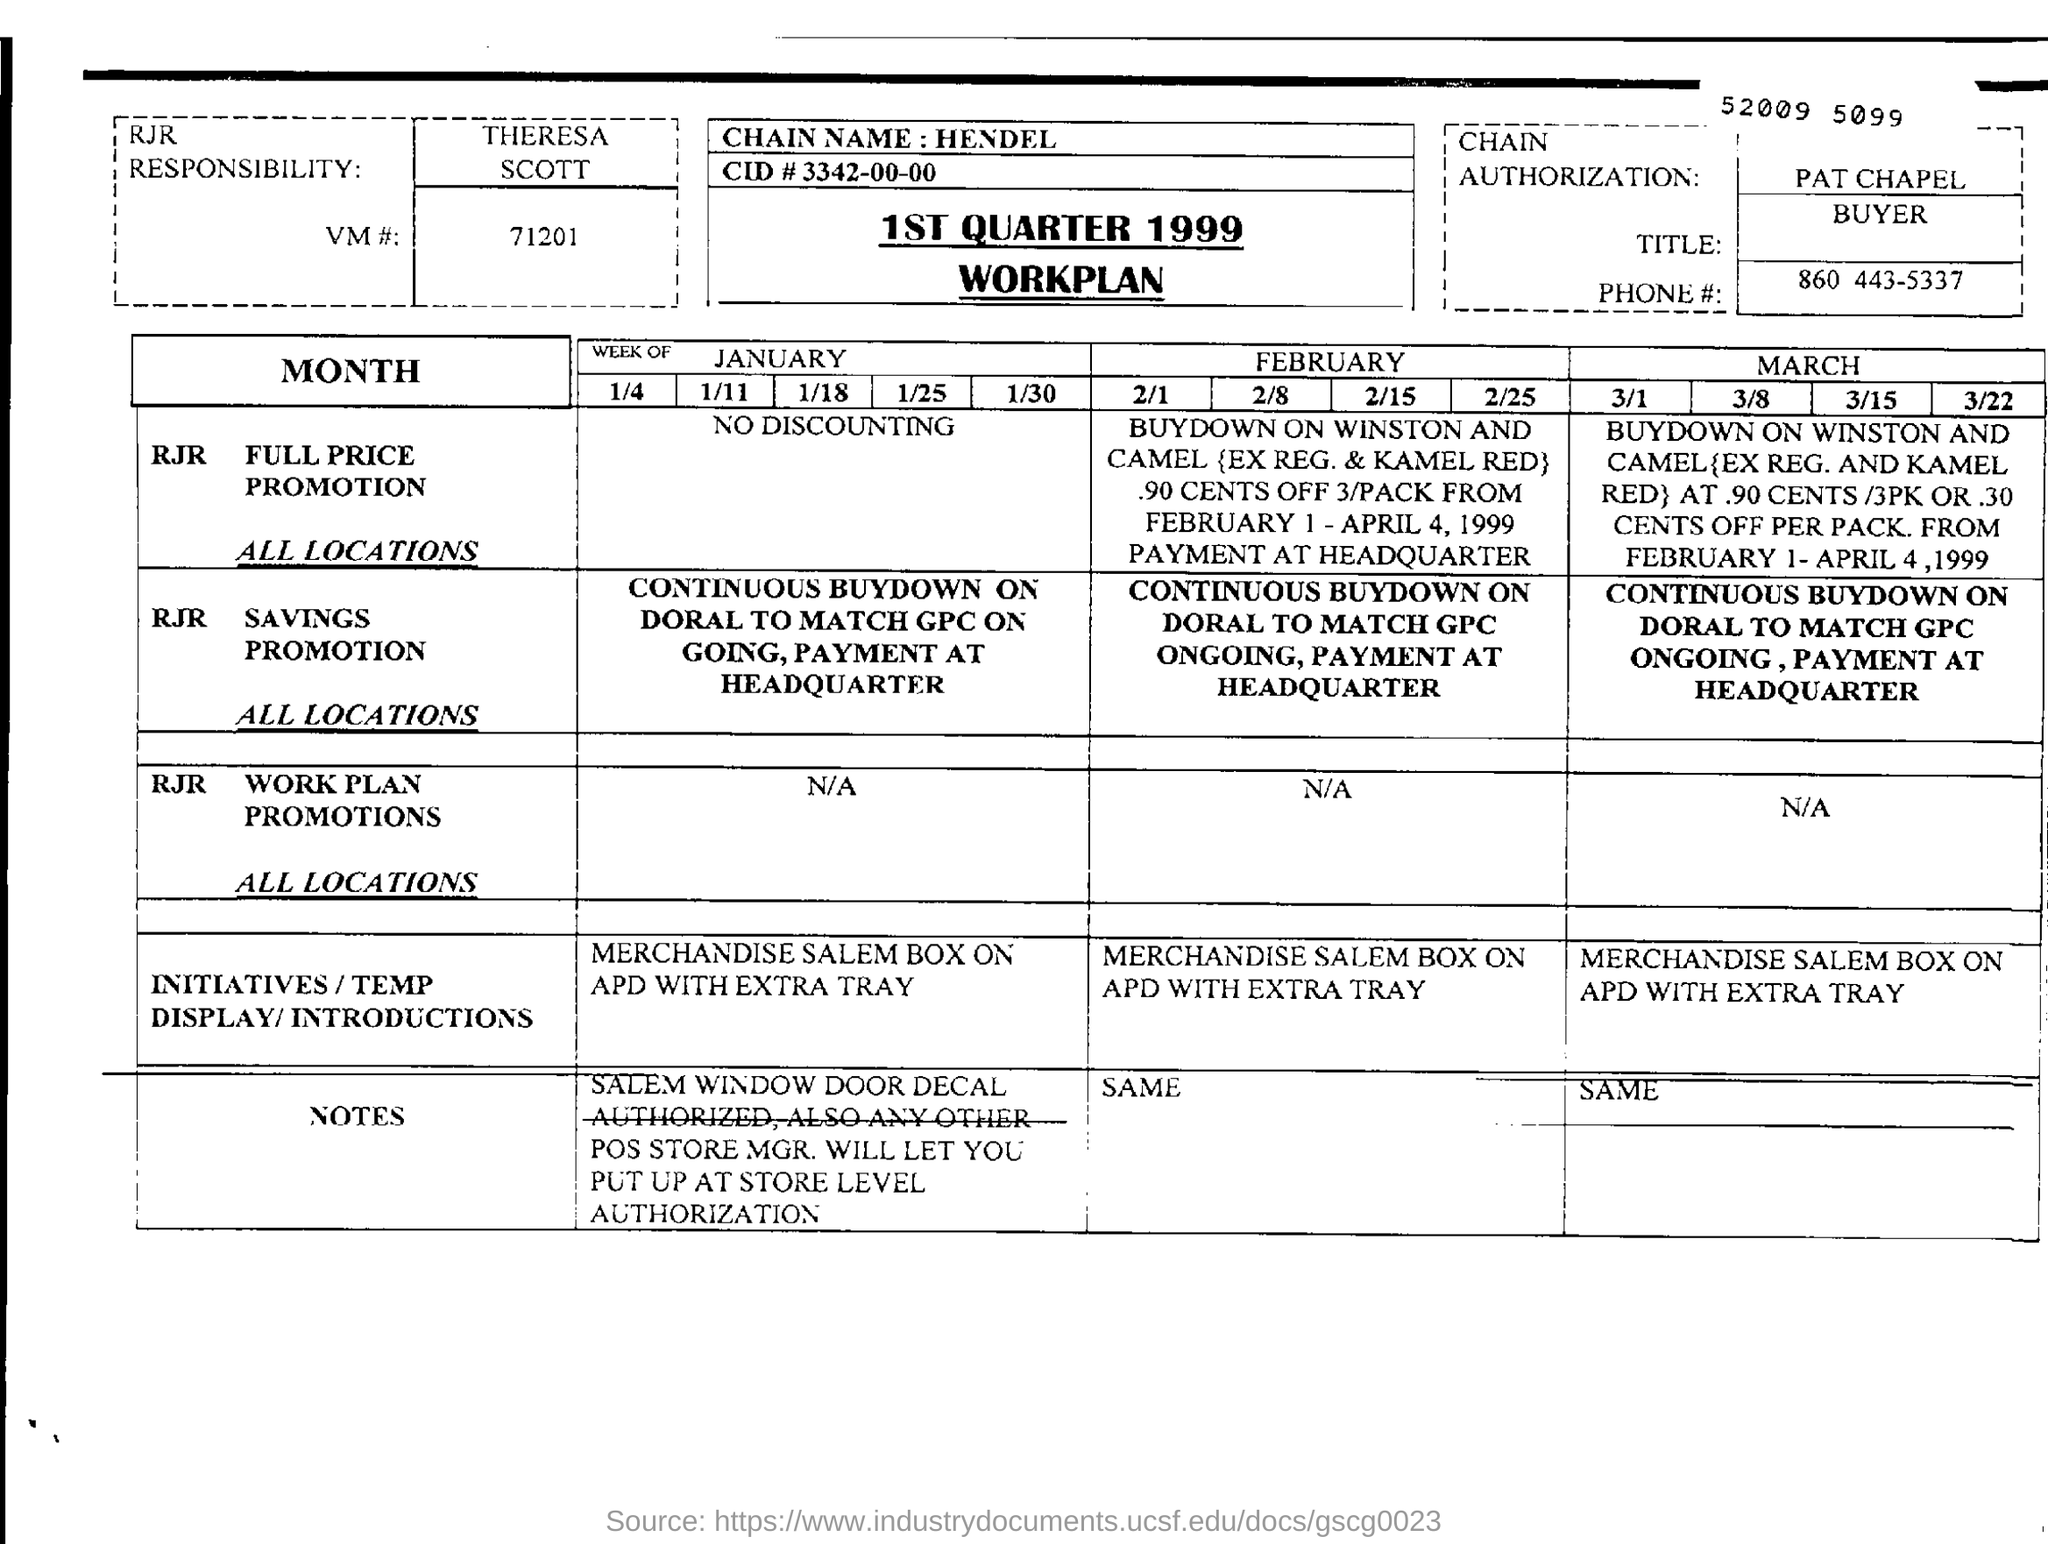Specify some key components in this picture. The workplan is applicable to the year 1999. The responsibility for chain authorization is assigned to Pat Chapel. 